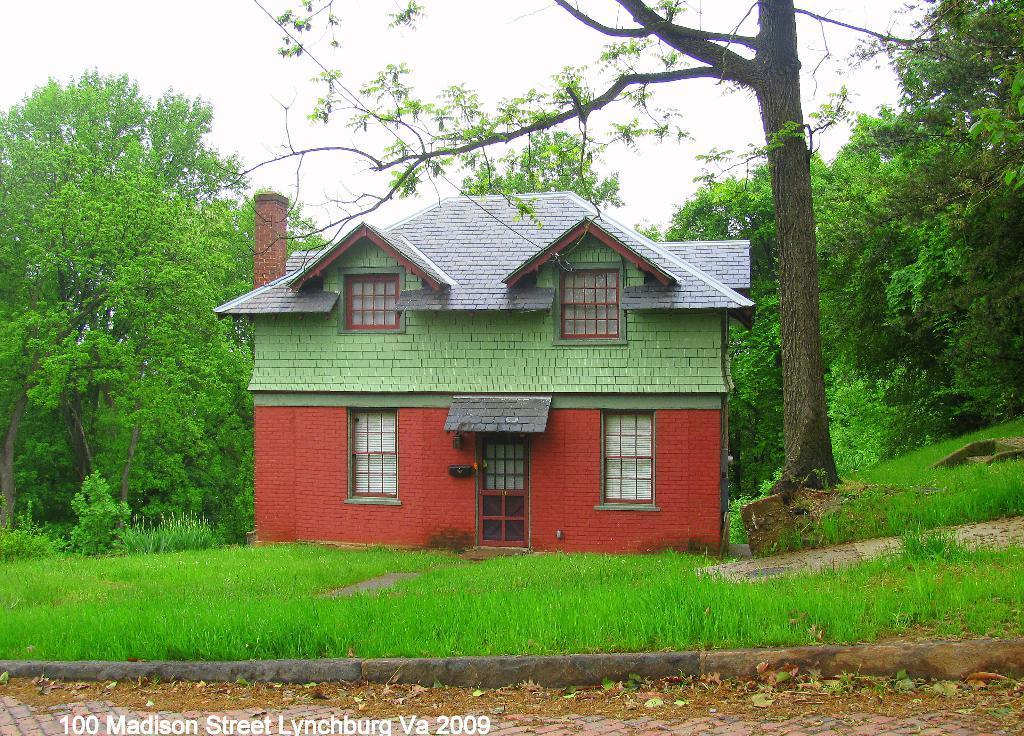Can you describe this image briefly? In the center of the image there is a house. On the right side of the image we can see a tree. At the bottom we can see grass and road. In the background there are trees and sky. 